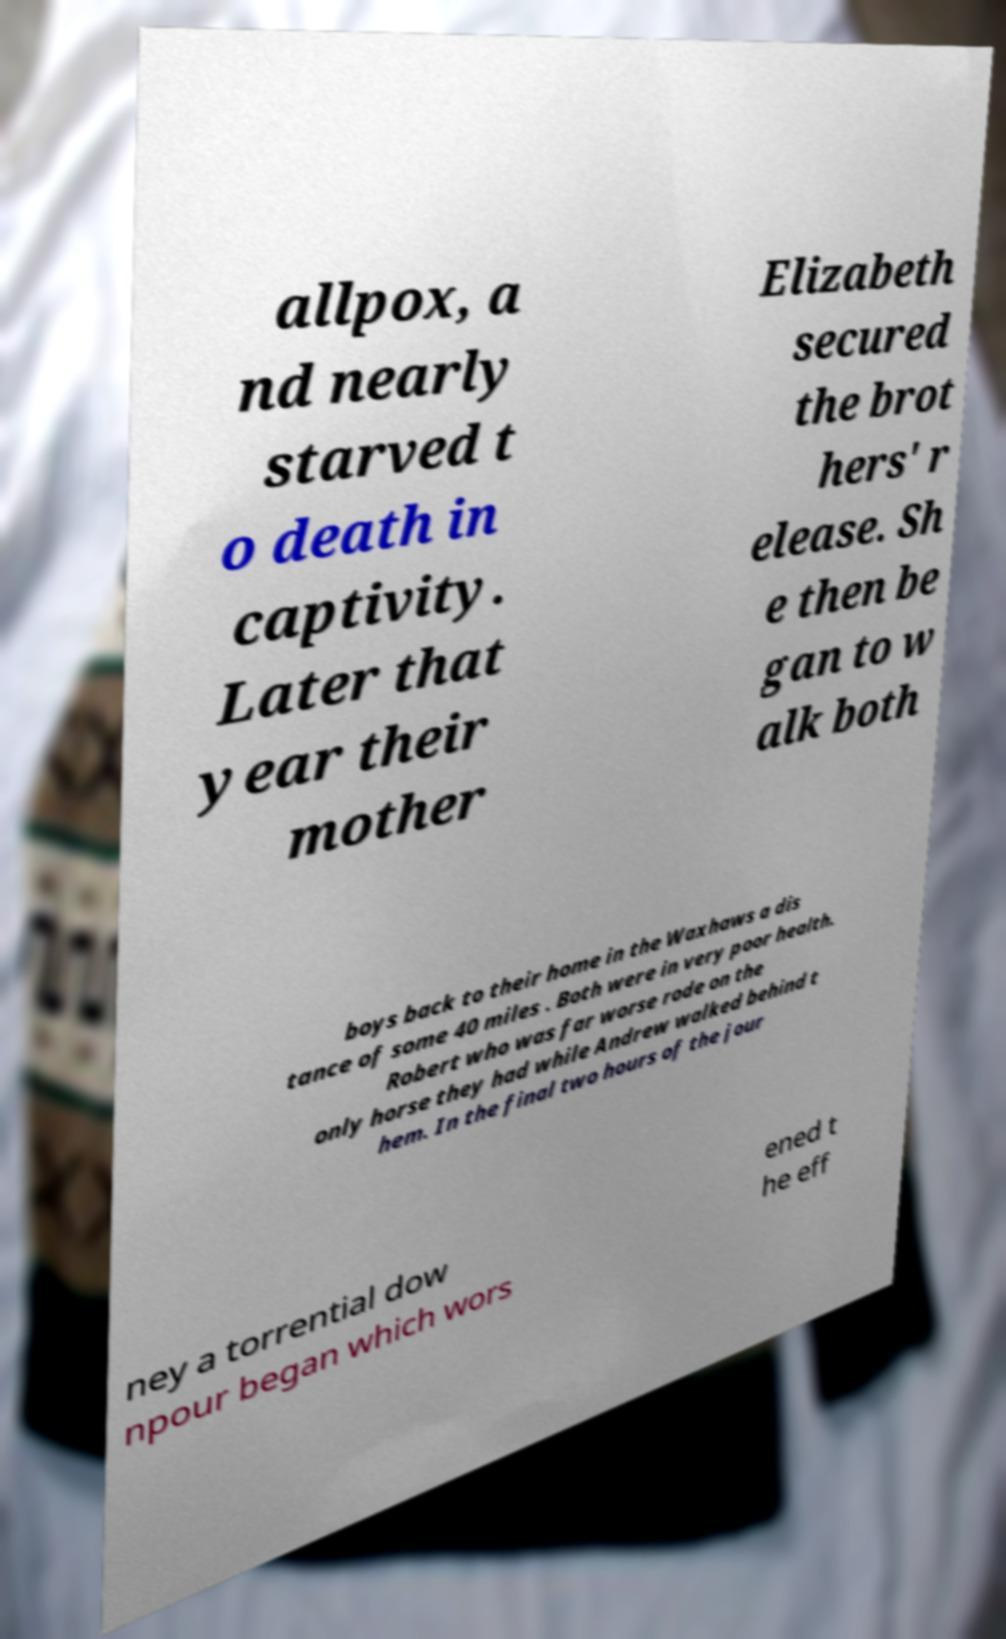What messages or text are displayed in this image? I need them in a readable, typed format. allpox, a nd nearly starved t o death in captivity. Later that year their mother Elizabeth secured the brot hers' r elease. Sh e then be gan to w alk both boys back to their home in the Waxhaws a dis tance of some 40 miles . Both were in very poor health. Robert who was far worse rode on the only horse they had while Andrew walked behind t hem. In the final two hours of the jour ney a torrential dow npour began which wors ened t he eff 